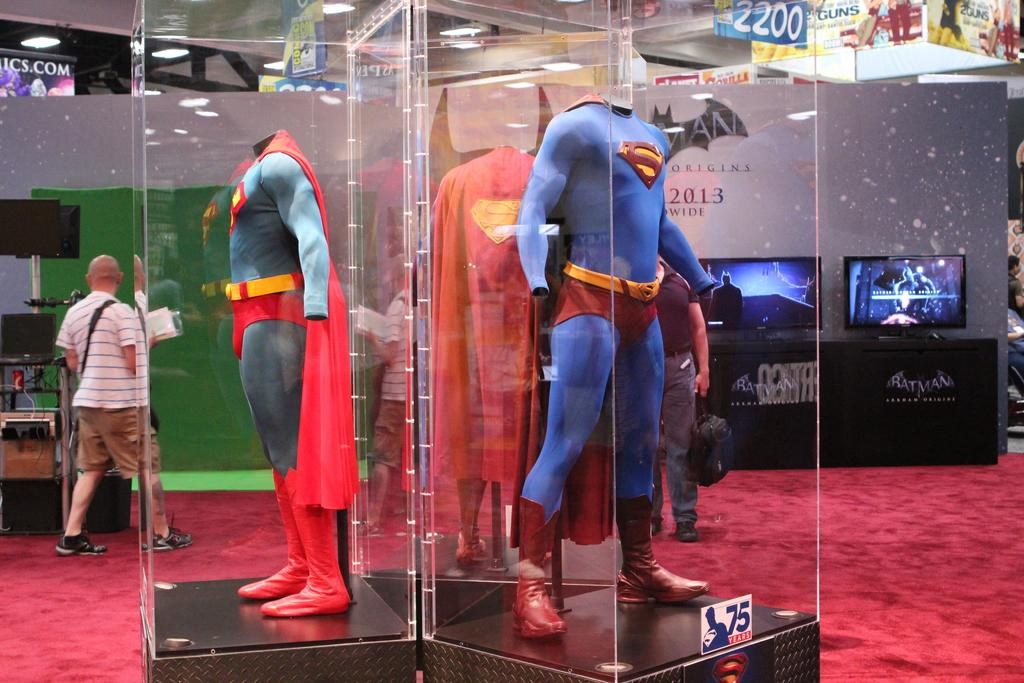<image>
Relay a brief, clear account of the picture shown. a superman costume that is behind some glass in a museum 